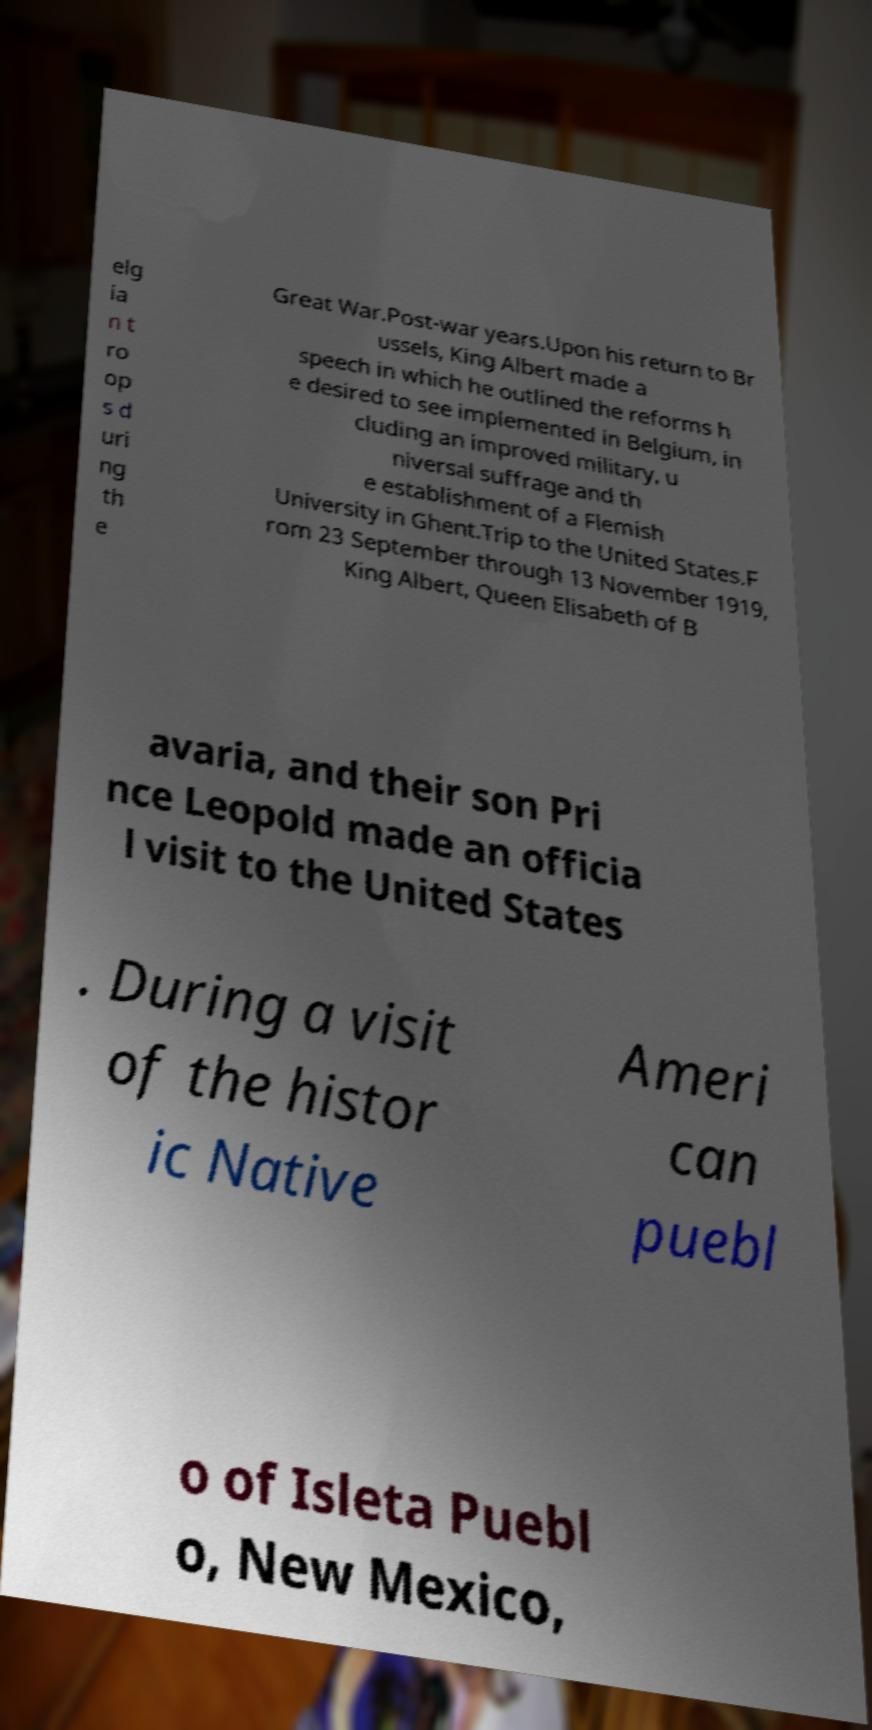I need the written content from this picture converted into text. Can you do that? elg ia n t ro op s d uri ng th e Great War.Post-war years.Upon his return to Br ussels, King Albert made a speech in which he outlined the reforms h e desired to see implemented in Belgium, in cluding an improved military, u niversal suffrage and th e establishment of a Flemish University in Ghent.Trip to the United States.F rom 23 September through 13 November 1919, King Albert, Queen Elisabeth of B avaria, and their son Pri nce Leopold made an officia l visit to the United States . During a visit of the histor ic Native Ameri can puebl o of Isleta Puebl o, New Mexico, 